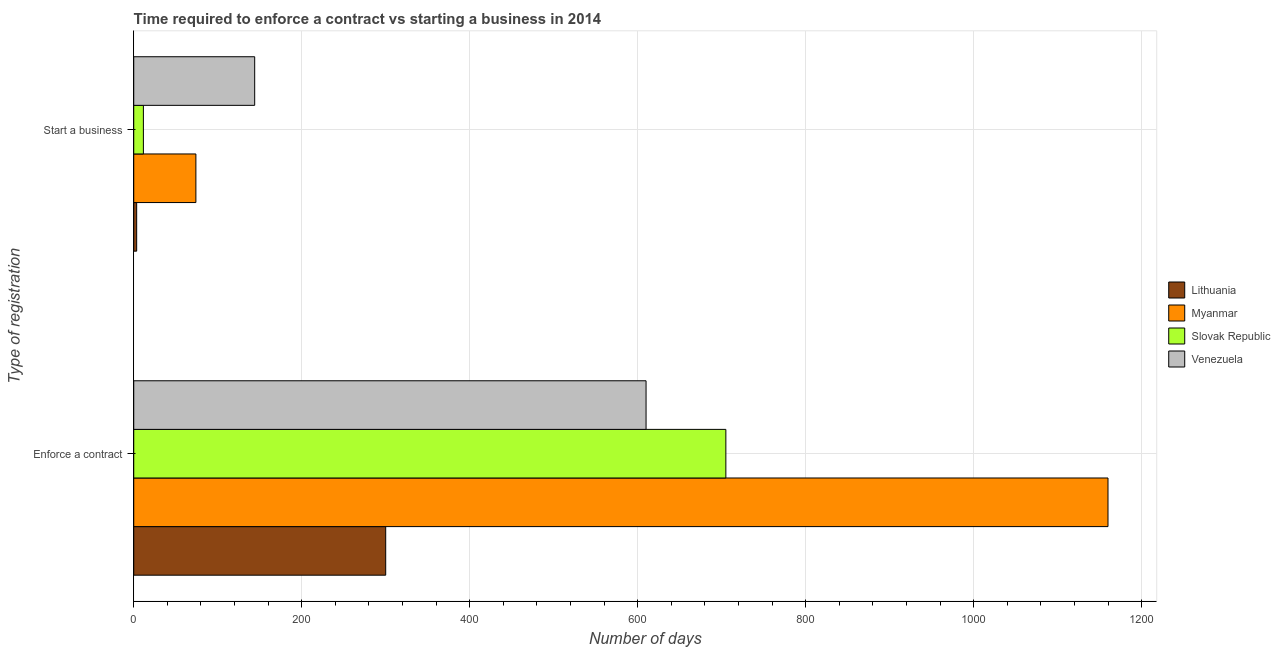How many different coloured bars are there?
Give a very brief answer. 4. Are the number of bars per tick equal to the number of legend labels?
Your answer should be compact. Yes. How many bars are there on the 1st tick from the bottom?
Your response must be concise. 4. What is the label of the 2nd group of bars from the top?
Your answer should be very brief. Enforce a contract. What is the number of days to enforece a contract in Myanmar?
Keep it short and to the point. 1160. Across all countries, what is the maximum number of days to start a business?
Provide a succinct answer. 144. In which country was the number of days to start a business maximum?
Give a very brief answer. Venezuela. In which country was the number of days to enforece a contract minimum?
Offer a very short reply. Lithuania. What is the total number of days to enforece a contract in the graph?
Ensure brevity in your answer.  2775. What is the difference between the number of days to enforece a contract in Slovak Republic and that in Lithuania?
Offer a very short reply. 405. What is the difference between the number of days to start a business in Myanmar and the number of days to enforece a contract in Lithuania?
Make the answer very short. -226. What is the average number of days to start a business per country?
Keep it short and to the point. 58.25. What is the difference between the number of days to enforece a contract and number of days to start a business in Lithuania?
Keep it short and to the point. 296.5. In how many countries, is the number of days to enforece a contract greater than 480 days?
Make the answer very short. 3. What is the ratio of the number of days to start a business in Venezuela to that in Slovak Republic?
Your answer should be compact. 12.52. What does the 3rd bar from the top in Enforce a contract represents?
Give a very brief answer. Myanmar. What does the 3rd bar from the bottom in Start a business represents?
Provide a short and direct response. Slovak Republic. How many bars are there?
Offer a terse response. 8. Are all the bars in the graph horizontal?
Offer a very short reply. Yes. How many countries are there in the graph?
Your answer should be compact. 4. What is the difference between two consecutive major ticks on the X-axis?
Give a very brief answer. 200. Does the graph contain any zero values?
Offer a terse response. No. How are the legend labels stacked?
Give a very brief answer. Vertical. What is the title of the graph?
Offer a very short reply. Time required to enforce a contract vs starting a business in 2014. Does "Trinidad and Tobago" appear as one of the legend labels in the graph?
Make the answer very short. No. What is the label or title of the X-axis?
Provide a succinct answer. Number of days. What is the label or title of the Y-axis?
Offer a very short reply. Type of registration. What is the Number of days of Lithuania in Enforce a contract?
Offer a very short reply. 300. What is the Number of days in Myanmar in Enforce a contract?
Give a very brief answer. 1160. What is the Number of days of Slovak Republic in Enforce a contract?
Your answer should be very brief. 705. What is the Number of days of Venezuela in Enforce a contract?
Keep it short and to the point. 610. What is the Number of days in Lithuania in Start a business?
Your response must be concise. 3.5. What is the Number of days of Venezuela in Start a business?
Offer a terse response. 144. Across all Type of registration, what is the maximum Number of days of Lithuania?
Make the answer very short. 300. Across all Type of registration, what is the maximum Number of days of Myanmar?
Your answer should be very brief. 1160. Across all Type of registration, what is the maximum Number of days in Slovak Republic?
Your answer should be compact. 705. Across all Type of registration, what is the maximum Number of days of Venezuela?
Your response must be concise. 610. Across all Type of registration, what is the minimum Number of days of Venezuela?
Keep it short and to the point. 144. What is the total Number of days in Lithuania in the graph?
Keep it short and to the point. 303.5. What is the total Number of days in Myanmar in the graph?
Ensure brevity in your answer.  1234. What is the total Number of days in Slovak Republic in the graph?
Ensure brevity in your answer.  716.5. What is the total Number of days in Venezuela in the graph?
Your response must be concise. 754. What is the difference between the Number of days in Lithuania in Enforce a contract and that in Start a business?
Provide a succinct answer. 296.5. What is the difference between the Number of days in Myanmar in Enforce a contract and that in Start a business?
Offer a very short reply. 1086. What is the difference between the Number of days in Slovak Republic in Enforce a contract and that in Start a business?
Your response must be concise. 693.5. What is the difference between the Number of days of Venezuela in Enforce a contract and that in Start a business?
Make the answer very short. 466. What is the difference between the Number of days of Lithuania in Enforce a contract and the Number of days of Myanmar in Start a business?
Your answer should be compact. 226. What is the difference between the Number of days in Lithuania in Enforce a contract and the Number of days in Slovak Republic in Start a business?
Offer a terse response. 288.5. What is the difference between the Number of days of Lithuania in Enforce a contract and the Number of days of Venezuela in Start a business?
Offer a very short reply. 156. What is the difference between the Number of days of Myanmar in Enforce a contract and the Number of days of Slovak Republic in Start a business?
Your answer should be very brief. 1148.5. What is the difference between the Number of days in Myanmar in Enforce a contract and the Number of days in Venezuela in Start a business?
Provide a succinct answer. 1016. What is the difference between the Number of days in Slovak Republic in Enforce a contract and the Number of days in Venezuela in Start a business?
Provide a succinct answer. 561. What is the average Number of days in Lithuania per Type of registration?
Offer a very short reply. 151.75. What is the average Number of days of Myanmar per Type of registration?
Offer a terse response. 617. What is the average Number of days in Slovak Republic per Type of registration?
Make the answer very short. 358.25. What is the average Number of days of Venezuela per Type of registration?
Your answer should be very brief. 377. What is the difference between the Number of days of Lithuania and Number of days of Myanmar in Enforce a contract?
Your answer should be compact. -860. What is the difference between the Number of days of Lithuania and Number of days of Slovak Republic in Enforce a contract?
Give a very brief answer. -405. What is the difference between the Number of days of Lithuania and Number of days of Venezuela in Enforce a contract?
Provide a succinct answer. -310. What is the difference between the Number of days in Myanmar and Number of days in Slovak Republic in Enforce a contract?
Offer a very short reply. 455. What is the difference between the Number of days in Myanmar and Number of days in Venezuela in Enforce a contract?
Give a very brief answer. 550. What is the difference between the Number of days in Slovak Republic and Number of days in Venezuela in Enforce a contract?
Your answer should be compact. 95. What is the difference between the Number of days of Lithuania and Number of days of Myanmar in Start a business?
Offer a terse response. -70.5. What is the difference between the Number of days in Lithuania and Number of days in Venezuela in Start a business?
Make the answer very short. -140.5. What is the difference between the Number of days of Myanmar and Number of days of Slovak Republic in Start a business?
Provide a succinct answer. 62.5. What is the difference between the Number of days of Myanmar and Number of days of Venezuela in Start a business?
Ensure brevity in your answer.  -70. What is the difference between the Number of days in Slovak Republic and Number of days in Venezuela in Start a business?
Ensure brevity in your answer.  -132.5. What is the ratio of the Number of days in Lithuania in Enforce a contract to that in Start a business?
Offer a terse response. 85.71. What is the ratio of the Number of days in Myanmar in Enforce a contract to that in Start a business?
Offer a terse response. 15.68. What is the ratio of the Number of days in Slovak Republic in Enforce a contract to that in Start a business?
Keep it short and to the point. 61.3. What is the ratio of the Number of days of Venezuela in Enforce a contract to that in Start a business?
Make the answer very short. 4.24. What is the difference between the highest and the second highest Number of days in Lithuania?
Ensure brevity in your answer.  296.5. What is the difference between the highest and the second highest Number of days in Myanmar?
Provide a short and direct response. 1086. What is the difference between the highest and the second highest Number of days of Slovak Republic?
Ensure brevity in your answer.  693.5. What is the difference between the highest and the second highest Number of days in Venezuela?
Provide a succinct answer. 466. What is the difference between the highest and the lowest Number of days in Lithuania?
Provide a succinct answer. 296.5. What is the difference between the highest and the lowest Number of days of Myanmar?
Ensure brevity in your answer.  1086. What is the difference between the highest and the lowest Number of days in Slovak Republic?
Provide a short and direct response. 693.5. What is the difference between the highest and the lowest Number of days in Venezuela?
Your answer should be compact. 466. 